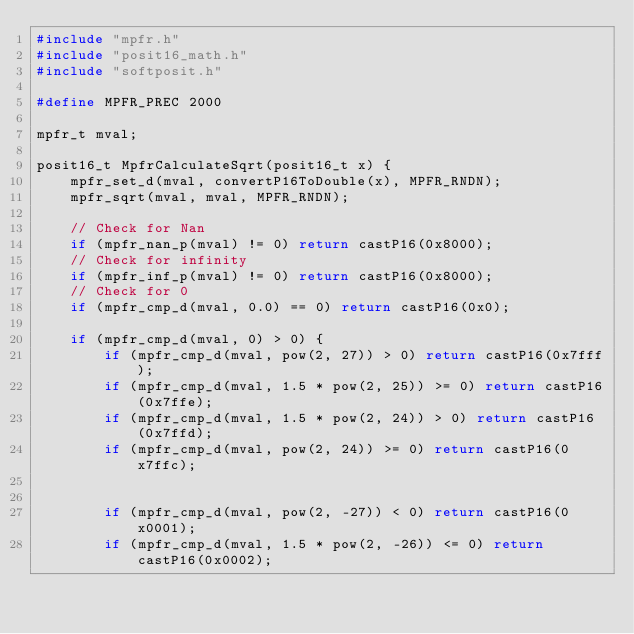<code> <loc_0><loc_0><loc_500><loc_500><_C++_>#include "mpfr.h"
#include "posit16_math.h"
#include "softposit.h"

#define MPFR_PREC 2000

mpfr_t mval;

posit16_t MpfrCalculateSqrt(posit16_t x) {
    mpfr_set_d(mval, convertP16ToDouble(x), MPFR_RNDN);
    mpfr_sqrt(mval, mval, MPFR_RNDN);
    
    // Check for Nan
    if (mpfr_nan_p(mval) != 0) return castP16(0x8000);
    // Check for infinity
    if (mpfr_inf_p(mval) != 0) return castP16(0x8000);
    // Check for 0
    if (mpfr_cmp_d(mval, 0.0) == 0) return castP16(0x0);
    
    if (mpfr_cmp_d(mval, 0) > 0) {
        if (mpfr_cmp_d(mval, pow(2, 27)) > 0) return castP16(0x7fff);
        if (mpfr_cmp_d(mval, 1.5 * pow(2, 25)) >= 0) return castP16(0x7ffe);
        if (mpfr_cmp_d(mval, 1.5 * pow(2, 24)) > 0) return castP16(0x7ffd);
        if (mpfr_cmp_d(mval, pow(2, 24)) >= 0) return castP16(0x7ffc);
        
        
        if (mpfr_cmp_d(mval, pow(2, -27)) < 0) return castP16(0x0001);
        if (mpfr_cmp_d(mval, 1.5 * pow(2, -26)) <= 0) return castP16(0x0002);</code> 